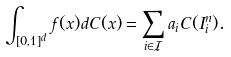<formula> <loc_0><loc_0><loc_500><loc_500>\int _ { [ 0 , 1 ] ^ { d } } f ( x ) d C ( x ) = \sum _ { i \in \mathcal { I } } a _ { i } C ( I ^ { n } _ { i } ) .</formula> 